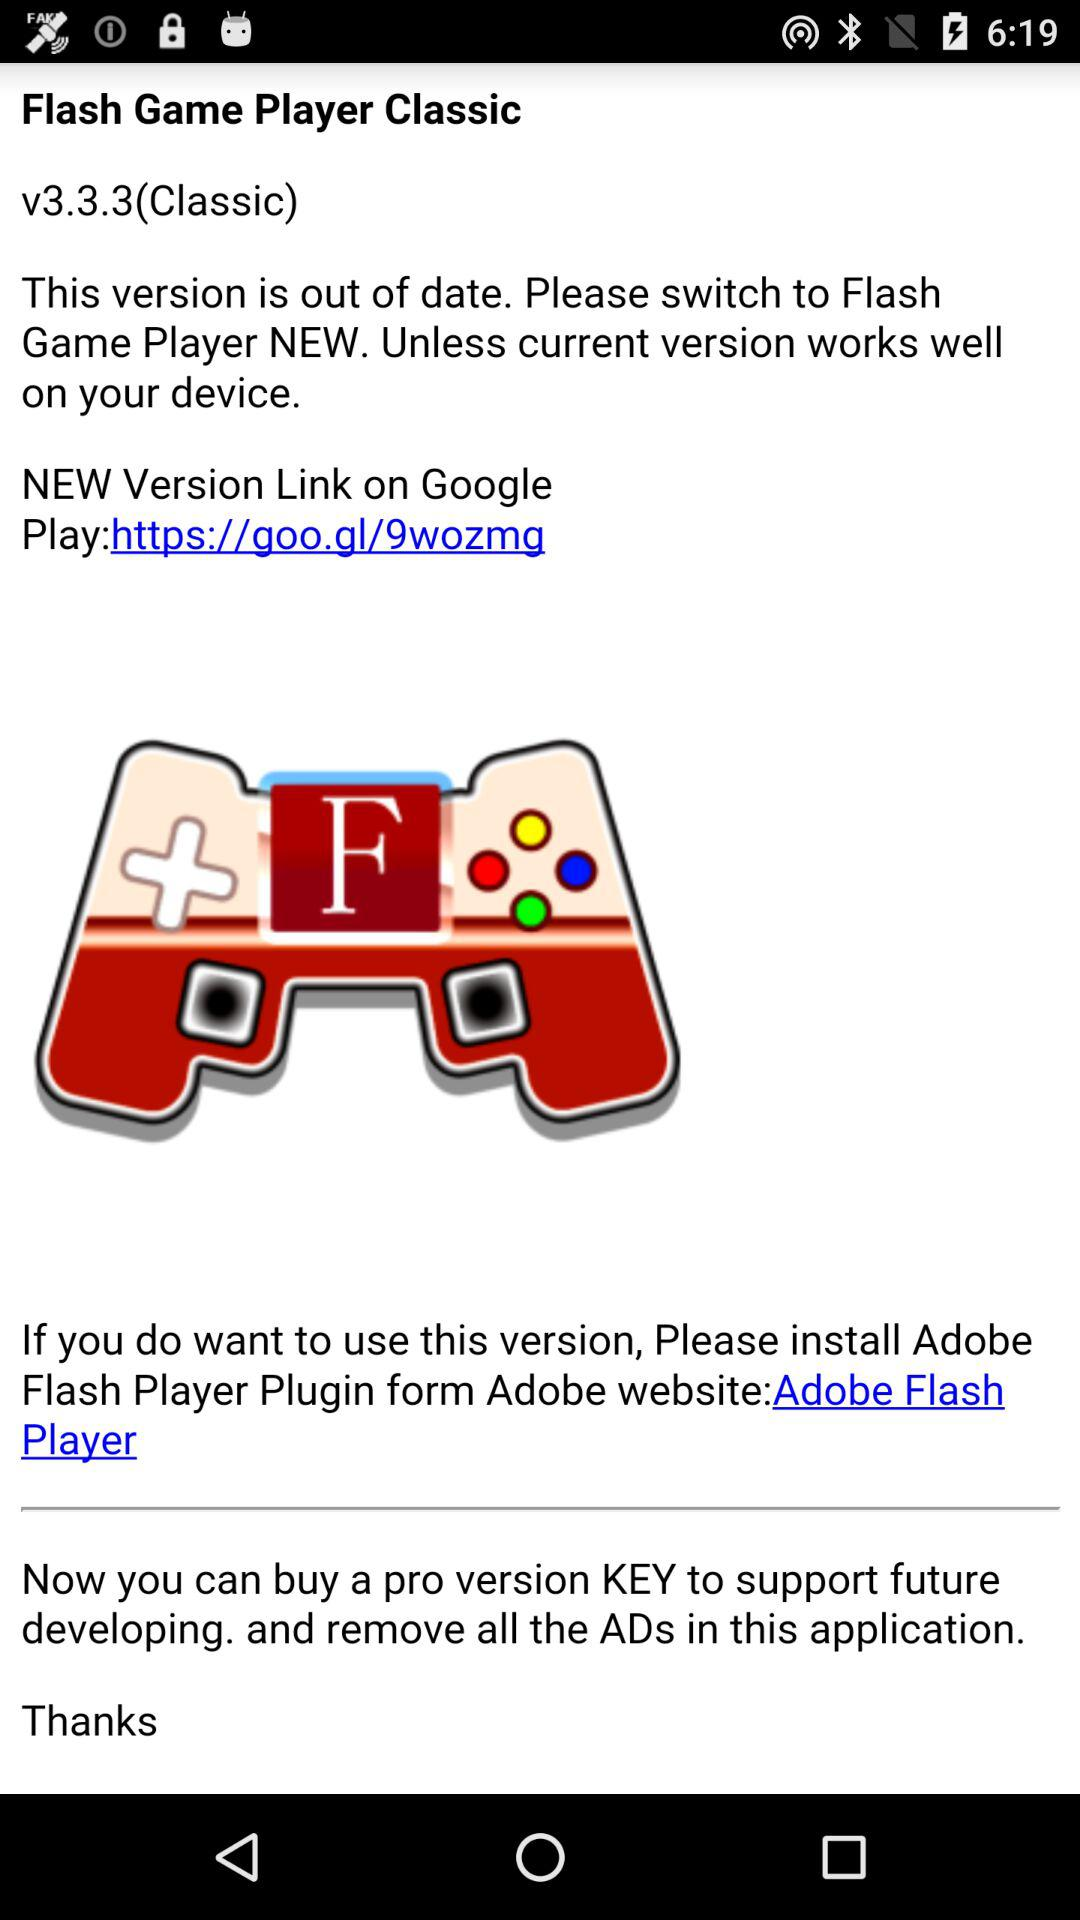What is the version? The version is 3.3.3. 